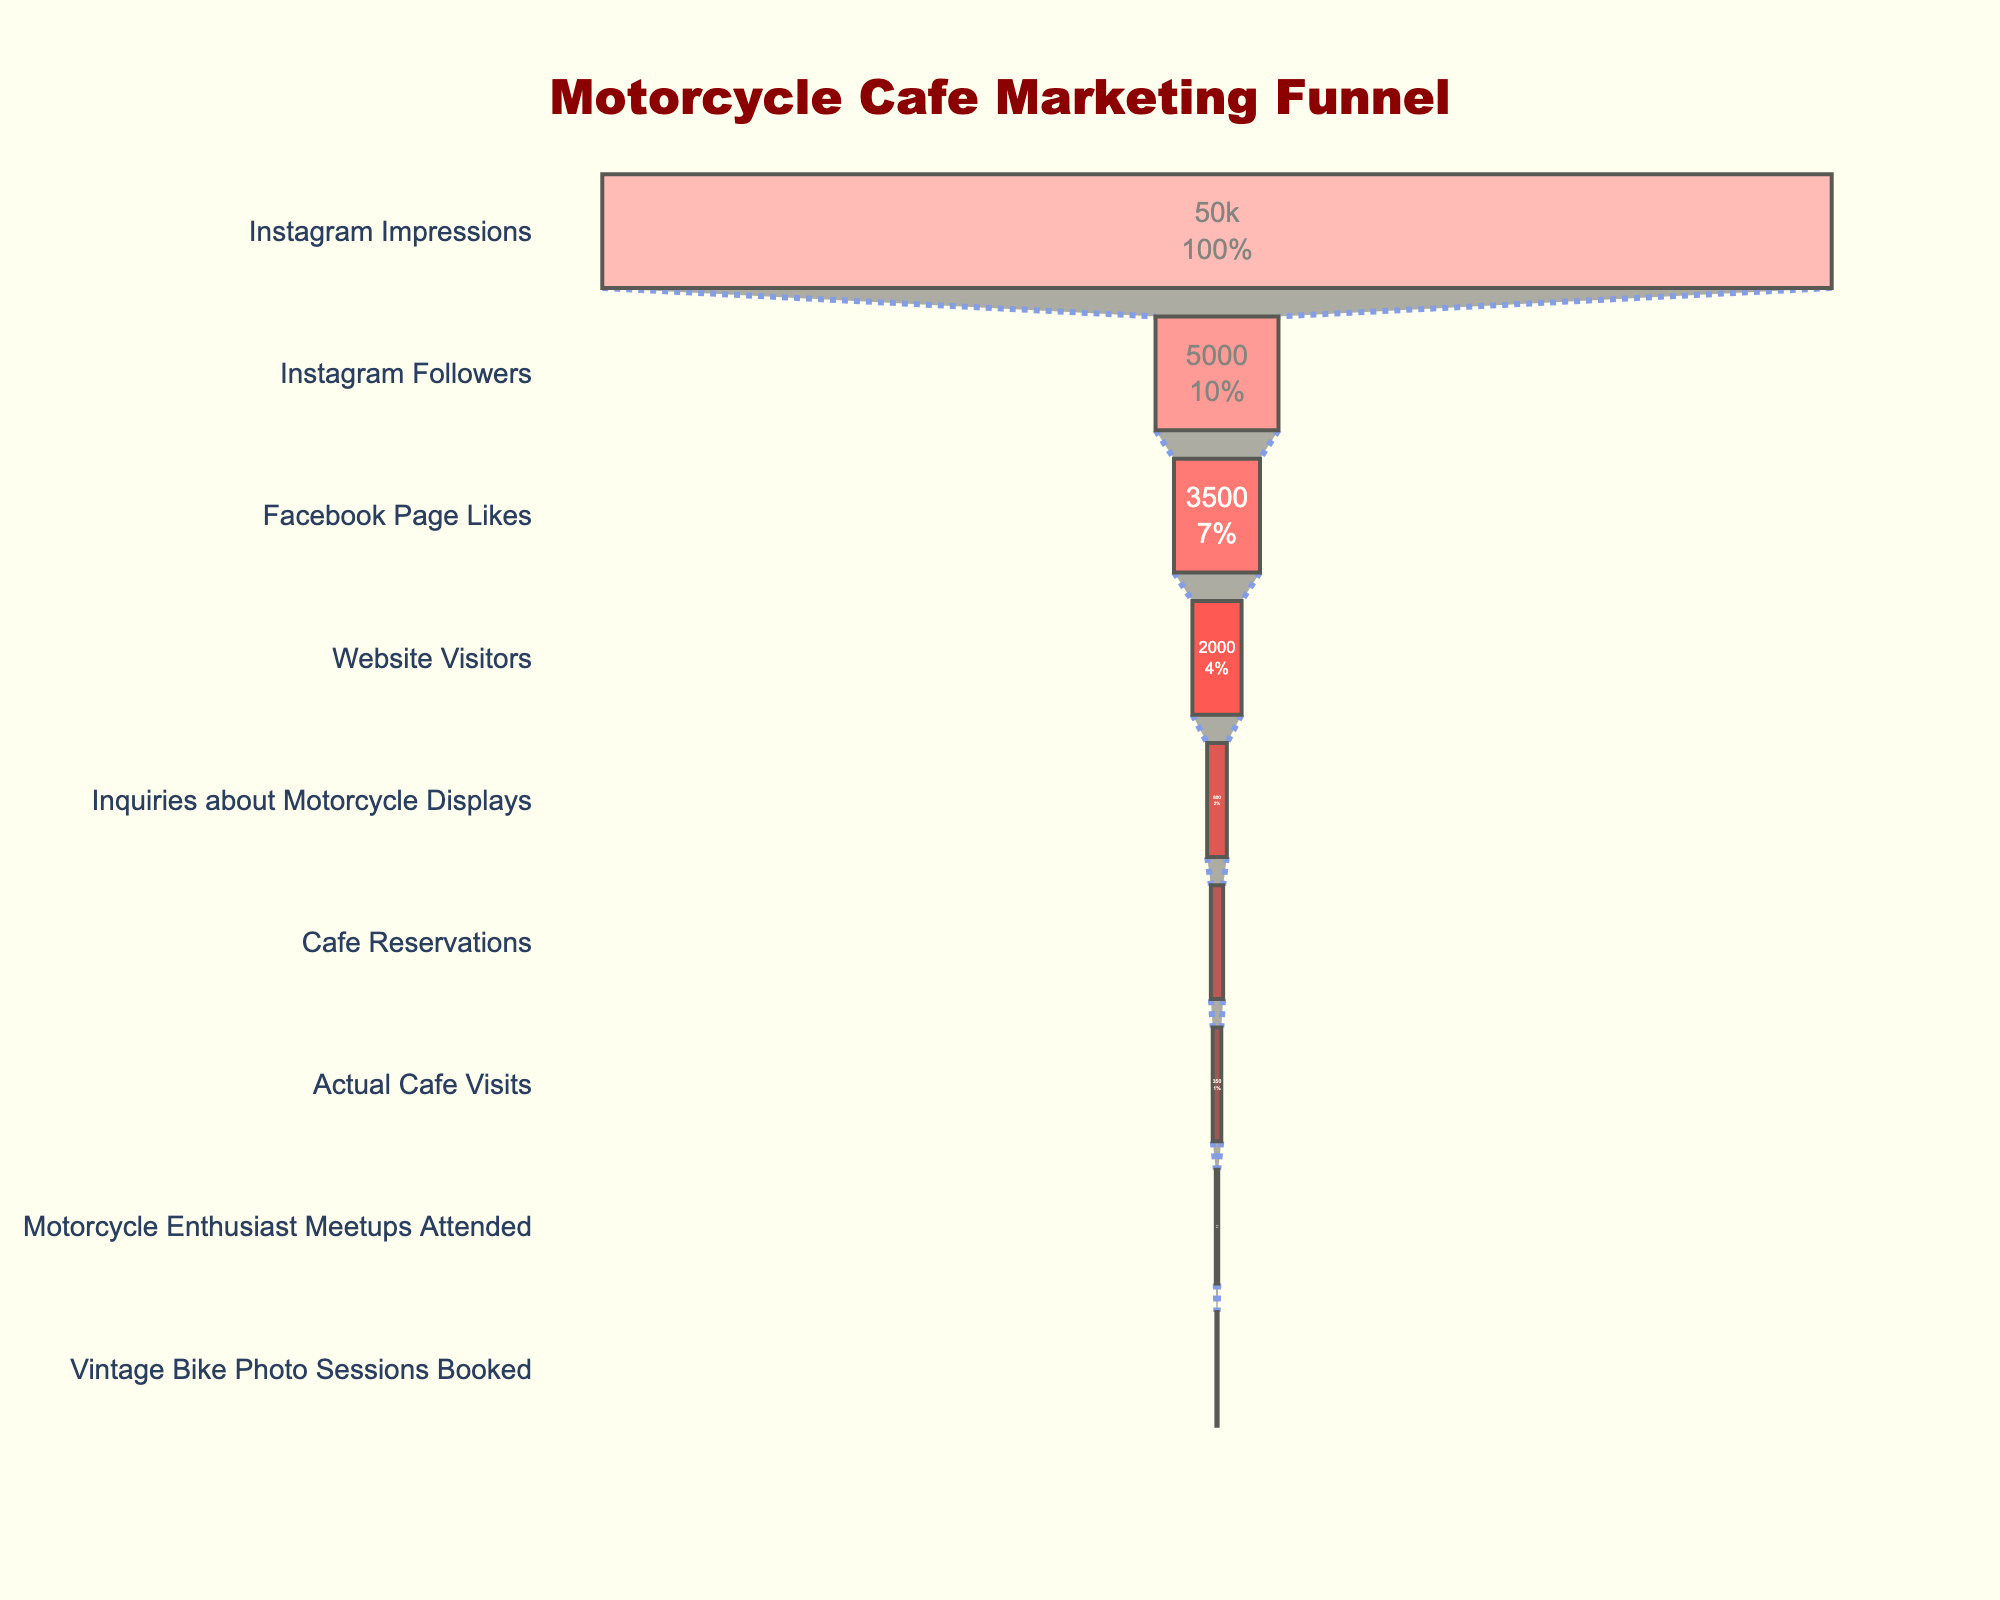What is the title of the figure? The title of the figure is visible at the top center part of the chart. The title provides an overview of what the funnel chart is representing.
Answer: "Motorcycle Cafe Marketing Funnel" What is the total count of Instagram Impressions and Website Visitors combined? You need to sum the counts for Instagram Impressions and Website Visitors. The count for Instagram Impressions is 50,000 and for Website Visitors is 2,000. So, 50,000 + 2,000 = 52,000.
Answer: 52,000 How many more Instagram Followers are there compared to Cafe Reservations? The count for Instagram Followers is 5,000, and Cafe Reservations is 500. Subtract 500 from 5,000 to find the difference. 5,000 - 500 = 4,500.
Answer: 4,500 Which stage has the highest count of individuals, and what is that count? The highest count is at the very top of the funnel chart. This indicates the first stage, which is Instagram Impressions with 50,000 counts.
Answer: Instagram Impressions, 50,000 What percentage of Instagram Impressions convert to actual Cafe Visits? To find the percentage, divide the count of Actual Cafe Visits by the count of Instagram Impressions and multiply by 100. For Instagram Impressions, it's 50,000 and Actual Cafe Visits is 350. (350 / 50,000) * 100 = 0.7%.
Answer: 0.7% What is the total count of all stages combined? Sum all the counts provided for each stage: 50,000 (Instagram Impressions) + 5,000 (Instagram Followers) + 3,500 (Facebook Page Likes) + 2,000 (Website Visitors) + 800 (Inquiries about Motorcycle Displays) + 500 (Cafe Reservations) + 350 (Actual Cafe Visits) + 100 (Motorcycle Enthusiast Meetups Attended) + 50 (Vintage Bike Photo Sessions Booked) = 62,300.
Answer: 62,300 Rank the stages from the one with the highest count to the one with the lowest count. Organize the stages based on their counts from highest to lowest: Instagram Impressions, Instagram Followers, Facebook Page Likes, Website Visitors, Inquiries about Motorcycle Displays, Cafe Reservations, Actual Cafe Visits, Motorcycle Enthusiast Meetups Attended, Vintage Bike Photo Sessions Booked. This can be determined by observing the data values in the funnel chart.
Answer: Instagram Impressions, Instagram Followers, Facebook Page Likes, Website Visitors, Inquiries about Motorcycle Displays, Cafe Reservations, Actual Cafe Visits, Motorcycle Enthusiast Meetups Attended, Vintage Bike Photo Sessions Booked Which stage has the smallest percentage drop from its preceding stage to the next stage? To detect the smallest drop, compute the percentage decrease for each subsequent pair of stages. For example:
1. Instagram Impressions to Instagram Followers: (5000/50000) * 100 = 10%
2. Instagram Followers to Facebook Page Likes: (3500/5000) * 100 = 70%
3. Facebook Page Likes to Website Visitors: (2000/3500) * 100 = 57.1%
4. Website Visitors to Inquiries about Motorcycle Displays: (800/2000) * 100 = 40%
5. Inquiries about Motorcycle Displays to Cafe Reservations: (500/800) * 100 = 62.5%
6. Cafe Reservations to Actual Cafe Visits: (350/500) * 100 = 70%
7. Actual Cafe Visits to Motorcycle Enthusiast Meetups Attended: (100/350) * 100 = 28.6%
8. Motorcycle Enthusiast Meetups Attended to Vintage Bike Photo Sessions Booked: (50/100) * 100 = 50%
The smallest drop is between Instagram Impressions to Instagram Followers, 10%.
Answer: Instagram Impressions to Instagram Followers What is the absolute difference between the counts of Facebook Page Likes and Motorcycle Enthusiast Meetups Attended? Subtract the count of Motorcycle Enthusiast Meetups Attended from Facebook Page Likes: 3,500 - 100 = 3,400.
Answer: 3,400 